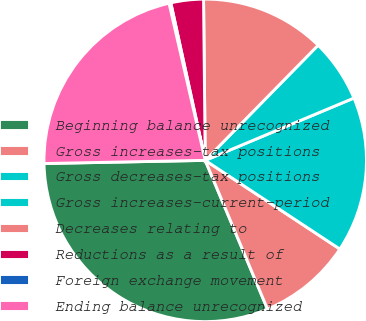Convert chart. <chart><loc_0><loc_0><loc_500><loc_500><pie_chart><fcel>Beginning balance unrecognized<fcel>Gross increases-tax positions<fcel>Gross decreases-tax positions<fcel>Gross increases-current-period<fcel>Decreases relating to<fcel>Reductions as a result of<fcel>Foreign exchange movement<fcel>Ending balance unrecognized<nl><fcel>31.0%<fcel>9.42%<fcel>15.59%<fcel>6.34%<fcel>12.51%<fcel>3.26%<fcel>0.18%<fcel>21.71%<nl></chart> 